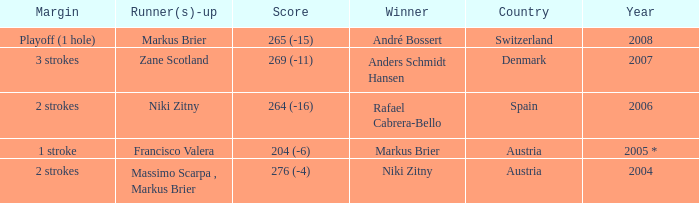What was the country when the margin was 2 strokes, and when the score was 276 (-4)? Austria. 